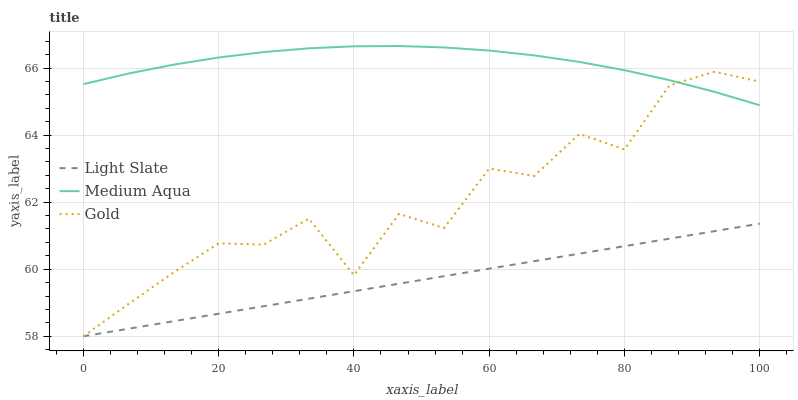Does Light Slate have the minimum area under the curve?
Answer yes or no. Yes. Does Medium Aqua have the maximum area under the curve?
Answer yes or no. Yes. Does Gold have the minimum area under the curve?
Answer yes or no. No. Does Gold have the maximum area under the curve?
Answer yes or no. No. Is Light Slate the smoothest?
Answer yes or no. Yes. Is Gold the roughest?
Answer yes or no. Yes. Is Medium Aqua the smoothest?
Answer yes or no. No. Is Medium Aqua the roughest?
Answer yes or no. No. Does Light Slate have the lowest value?
Answer yes or no. Yes. Does Medium Aqua have the lowest value?
Answer yes or no. No. Does Medium Aqua have the highest value?
Answer yes or no. Yes. Does Gold have the highest value?
Answer yes or no. No. Is Light Slate less than Medium Aqua?
Answer yes or no. Yes. Is Medium Aqua greater than Light Slate?
Answer yes or no. Yes. Does Light Slate intersect Gold?
Answer yes or no. Yes. Is Light Slate less than Gold?
Answer yes or no. No. Is Light Slate greater than Gold?
Answer yes or no. No. Does Light Slate intersect Medium Aqua?
Answer yes or no. No. 